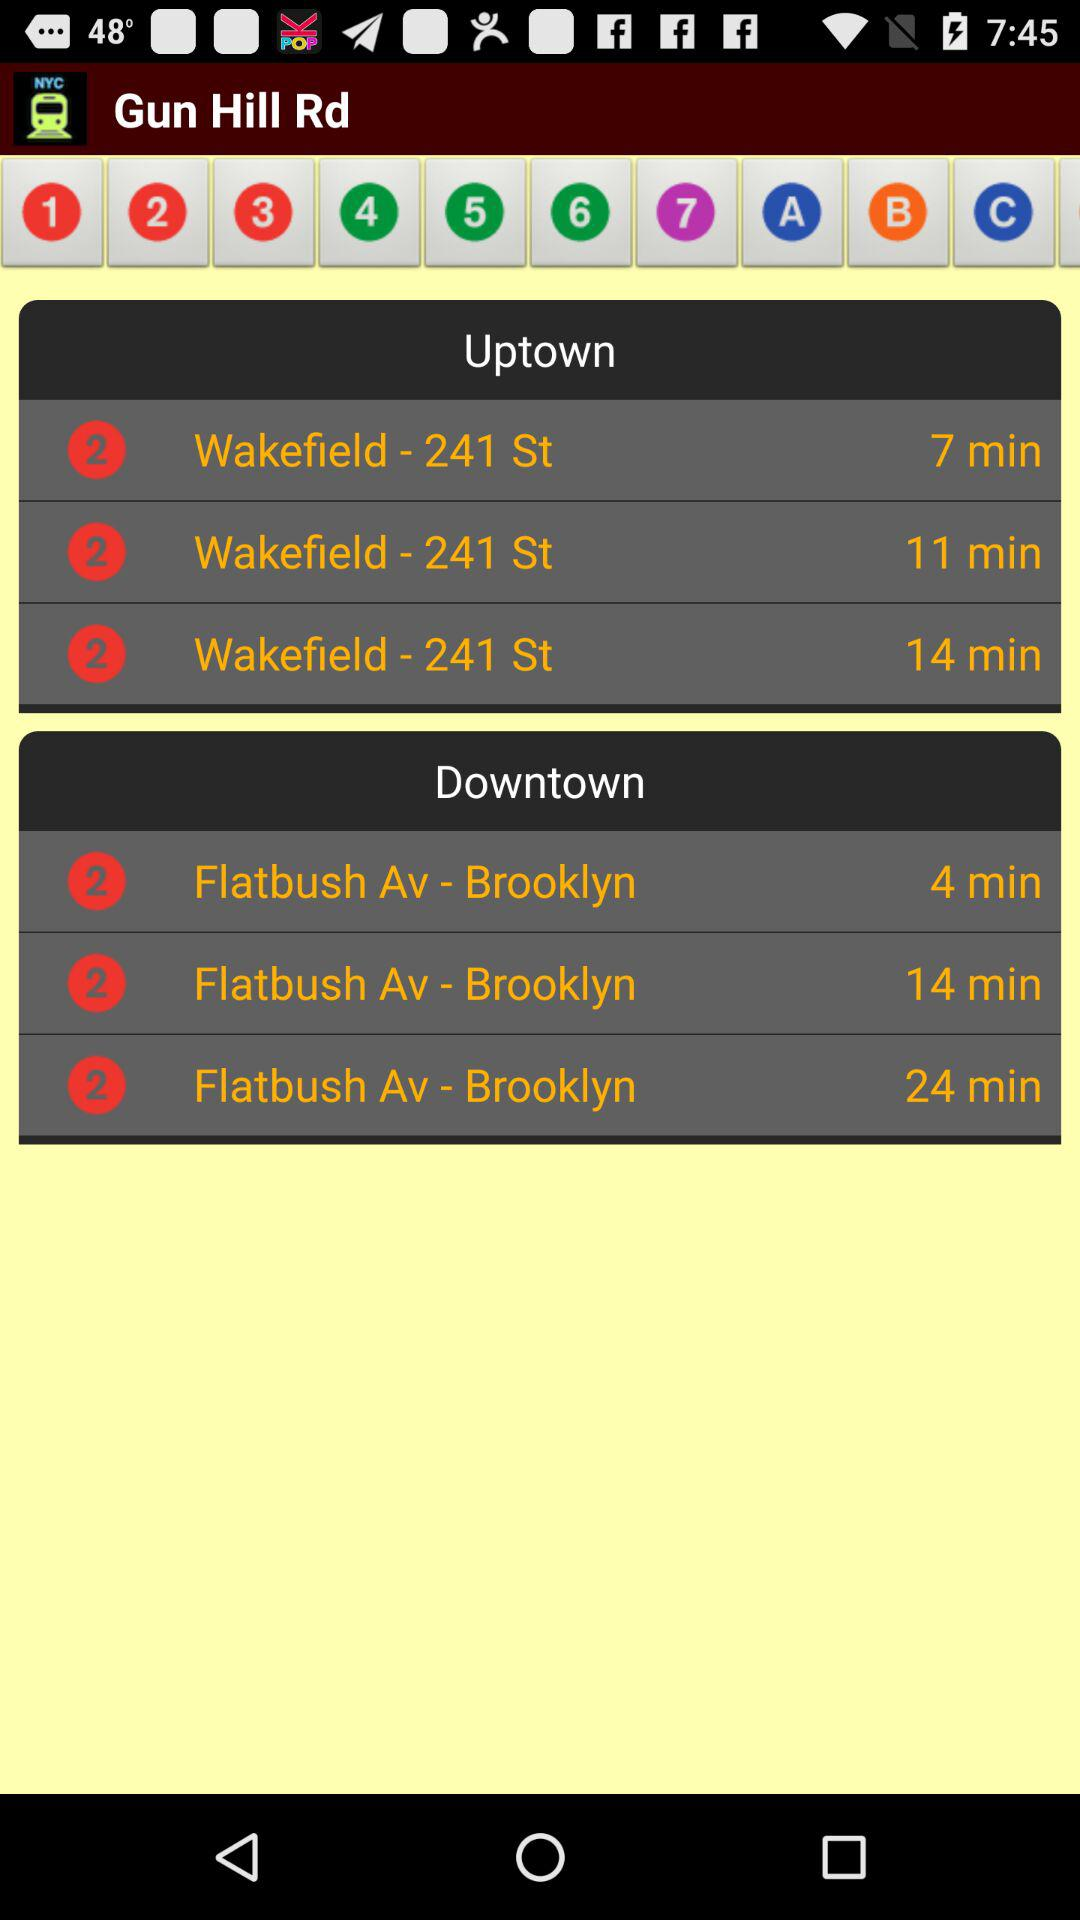What is the given location? The given location is Gun Hill Rd. 